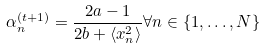Convert formula to latex. <formula><loc_0><loc_0><loc_500><loc_500>\alpha _ { n } ^ { ( t + 1 ) } = \frac { 2 a - 1 } { 2 b + \langle x _ { n } ^ { 2 } \rangle } \forall n \in \{ 1 , \dots , N \}</formula> 